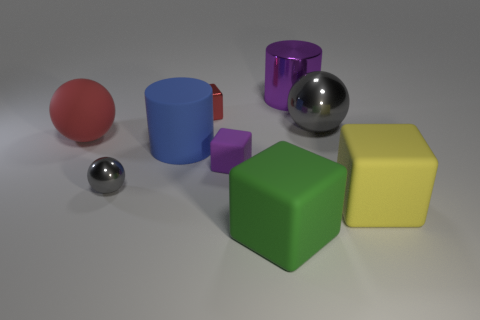Subtract all balls. How many objects are left? 6 Add 4 small purple matte cubes. How many small purple matte cubes are left? 5 Add 4 small purple cubes. How many small purple cubes exist? 5 Subtract 0 brown cylinders. How many objects are left? 9 Subtract all tiny red metallic objects. Subtract all big green objects. How many objects are left? 7 